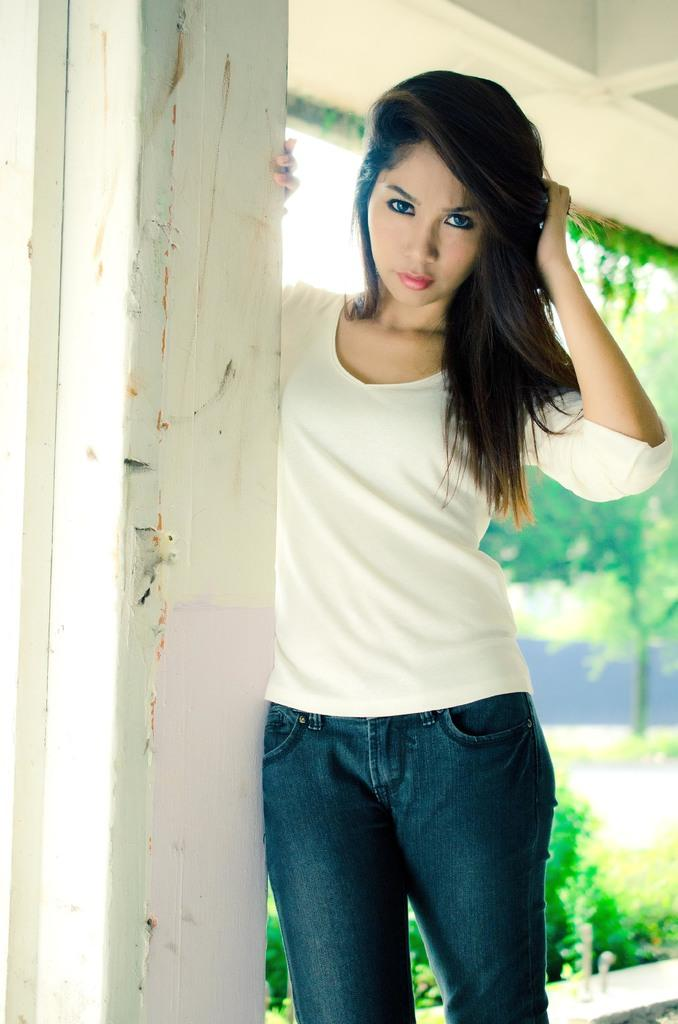Who is present in the image? There is a woman in the image. What is the woman doing in the image? The woman is standing beside a wall and posing for a photo. Can you see the woman kissing a chicken in the image? There is no chicken present in the image, and the woman is not kissing anything. 